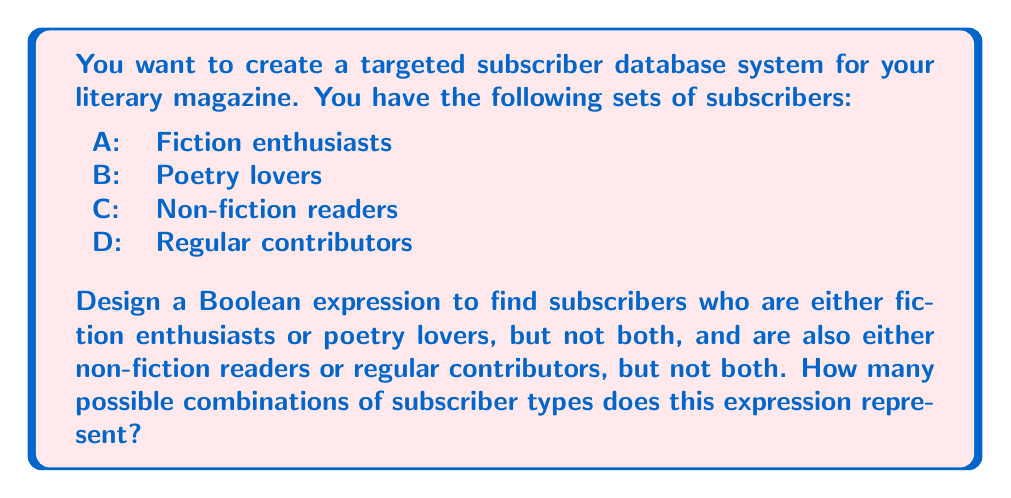Give your solution to this math problem. Let's approach this step-by-step:

1) First, we need to create a Boolean expression for the given conditions:
   - Either fiction enthusiasts or poetry lovers, but not both: $A \oplus B$
   - Either non-fiction readers or regular contributors, but not both: $C \oplus D$
   - We want subscribers who satisfy both these conditions

2) The final Boolean expression is therefore:
   $$(A \oplus B) \wedge (C \oplus D)$$

3) To find the number of possible combinations, we need to expand this expression:
   $$(A \oplus B) \wedge (C \oplus D) = (A \bar{B} + \bar{A}B) \wedge (C \bar{D} + \bar{C}D)$$

4) Expanding further:
   $$(A \bar{B}C \bar{D}) + (A \bar{B} \bar{C}D) + (\bar{A}BC \bar{D}) + (\bar{A}B \bar{C}D)$$

5) Each term in this expansion represents a unique combination:
   - $A \bar{B}C \bar{D}$: Fiction enthusiasts who are not poetry lovers, are non-fiction readers, and not regular contributors
   - $A \bar{B} \bar{C}D$: Fiction enthusiasts who are not poetry lovers, are not non-fiction readers, and are regular contributors
   - $\bar{A}BC \bar{D}$: Poetry lovers who are not fiction enthusiasts, are non-fiction readers, and not regular contributors
   - $\bar{A}B \bar{C}D$: Poetry lovers who are not fiction enthusiasts, are not non-fiction readers, and are regular contributors

6) Counting these terms, we can see that there are 4 possible combinations.
Answer: 4 combinations 